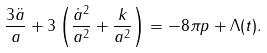<formula> <loc_0><loc_0><loc_500><loc_500>\frac { 3 \ddot { a } } { a } + 3 \left ( \frac { \dot { a } ^ { 2 } } { a ^ { 2 } } + \frac { k } { a ^ { 2 } } \right ) = - 8 \pi p + \Lambda ( t ) .</formula> 